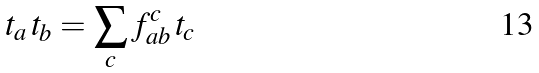<formula> <loc_0><loc_0><loc_500><loc_500>t _ { a } \, t _ { b } = \sum _ { c } f _ { a b } ^ { c } \, t _ { c }</formula> 